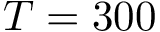<formula> <loc_0><loc_0><loc_500><loc_500>T = 3 0 0</formula> 